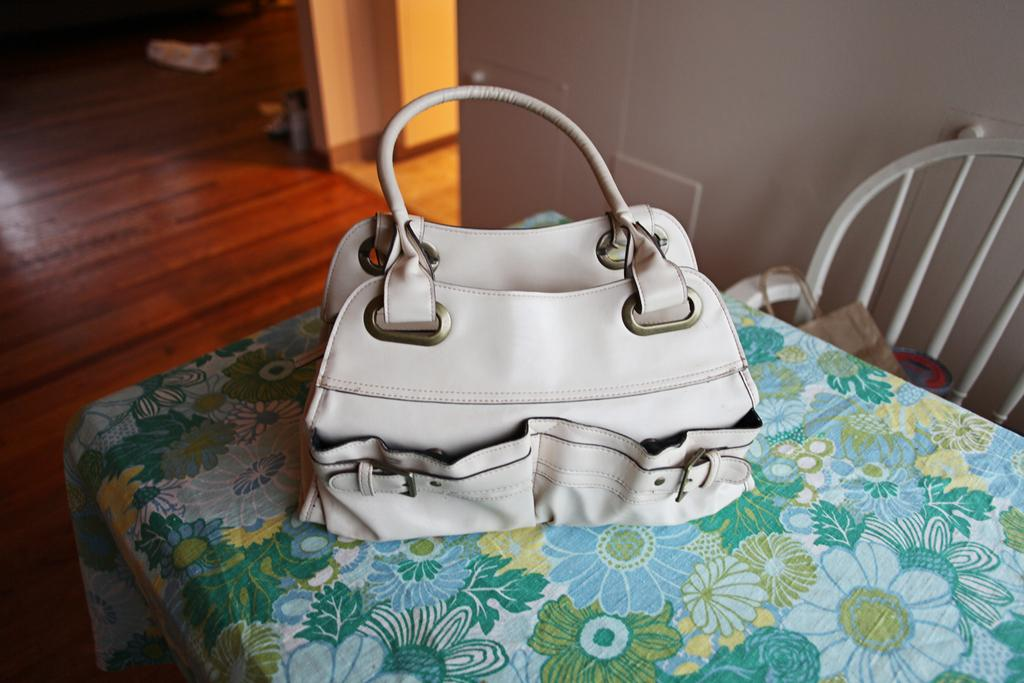What object is placed on the table in the image? There is a handbag on the table. What piece of furniture is located near the table? There is a chair beside the table. What type of magic trick is being performed with the handbag in the image? There is no magic trick being performed in the image; it simply shows a handbag on a table. Can you see any worms crawling on the handbag in the image? There are no worms present in the image; it only shows a handbag on a table. 